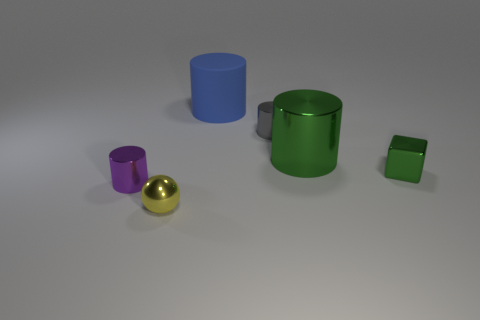Is there anything else that is the same material as the big blue cylinder?
Offer a very short reply. No. Is there any other thing that has the same shape as the tiny green metallic thing?
Offer a very short reply. No. How many brown objects are either tiny spheres or big objects?
Offer a very short reply. 0. Is the color of the tiny metal block the same as the cylinder that is to the right of the tiny gray metal cylinder?
Offer a very short reply. Yes. How many other objects are there of the same color as the large rubber thing?
Offer a very short reply. 0. Are there fewer tiny green shiny cubes than big purple matte cubes?
Keep it short and to the point. No. What number of green objects are right of the cylinder on the left side of the tiny shiny object that is in front of the small purple shiny cylinder?
Make the answer very short. 2. There is a green metal object that is behind the small green block; how big is it?
Offer a terse response. Large. There is a large object that is in front of the blue object; is it the same shape as the tiny yellow shiny object?
Your answer should be compact. No. There is a blue thing that is the same shape as the tiny gray metallic object; what material is it?
Keep it short and to the point. Rubber. 